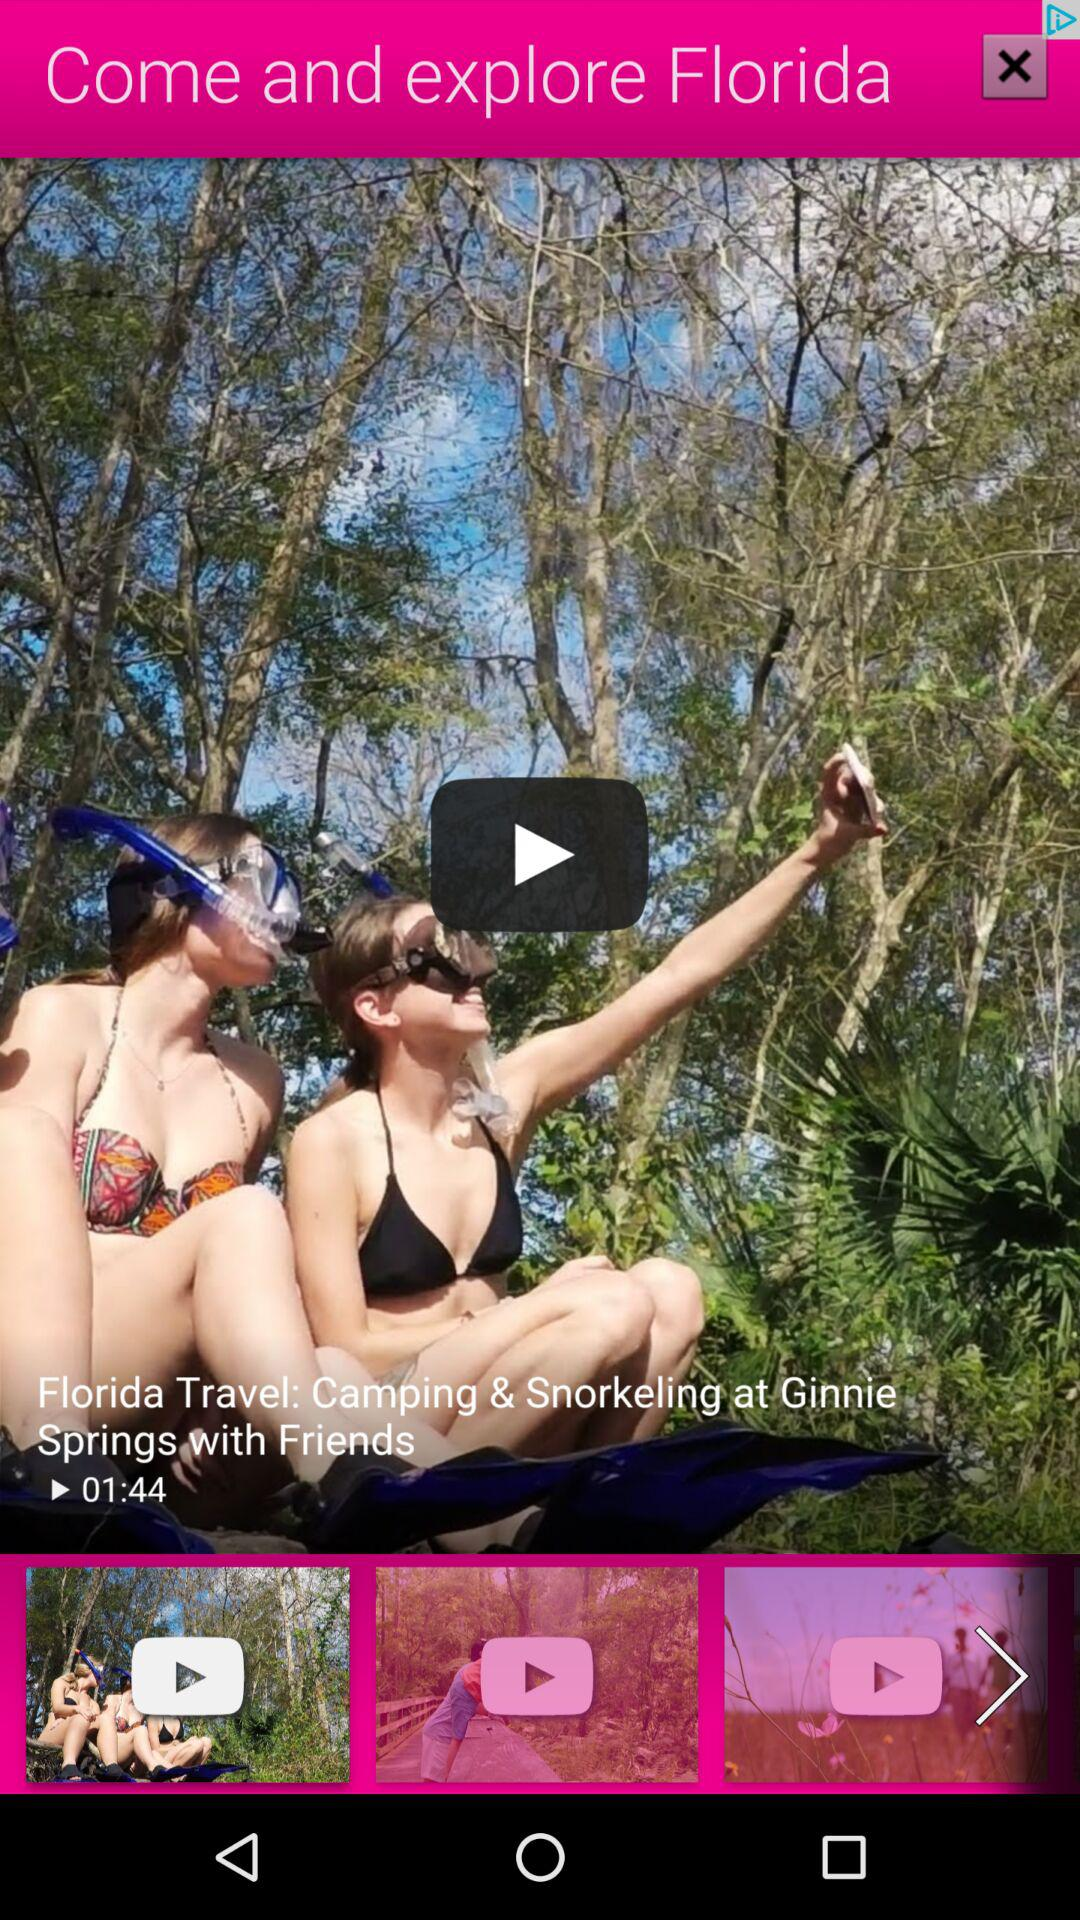What is the time duration of the video Florida travel? The time duration is 1 minute and 44 seconds. 